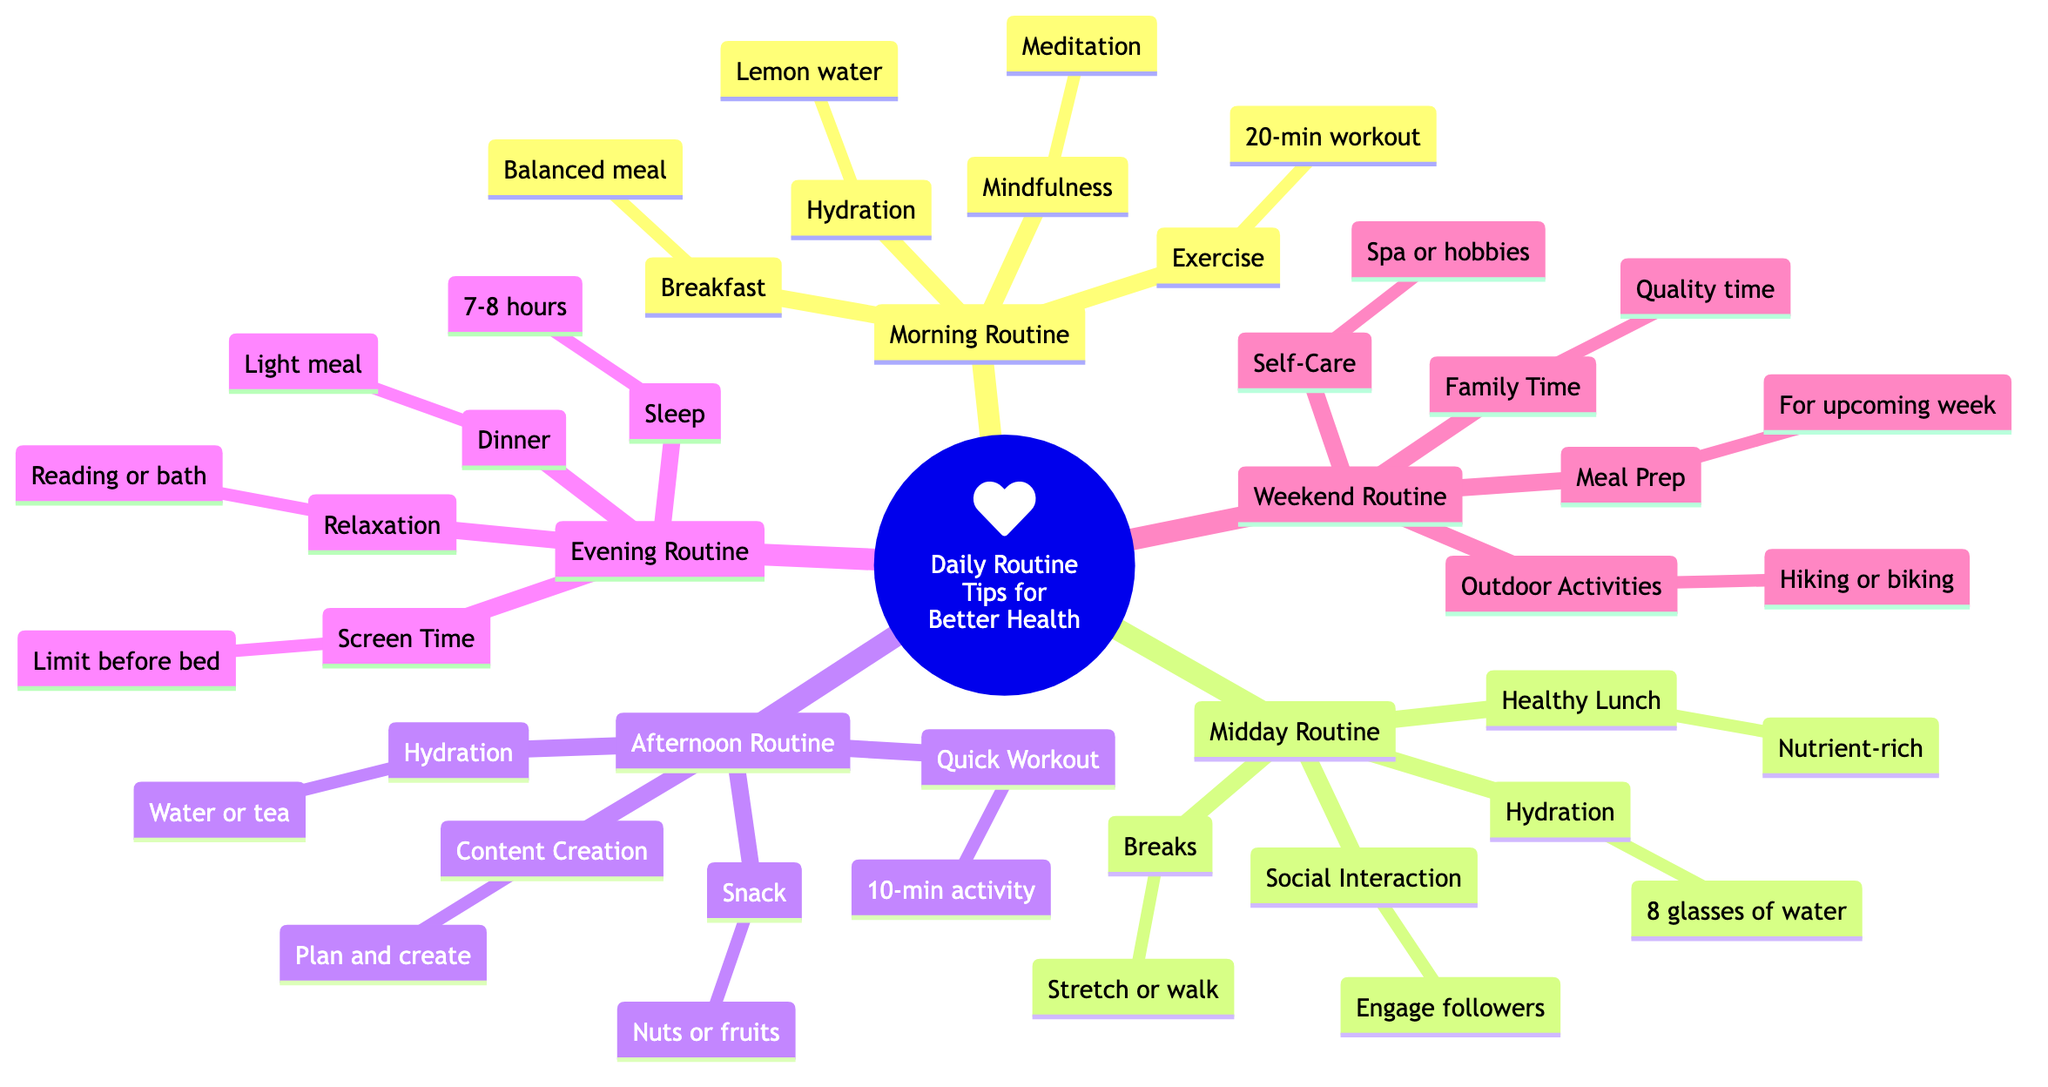what is the first suggestion in the morning routine? In the "Morning Routine" section of the mind map, the first listed suggestion is "Hydration," which recommends starting the day with a glass of lemon water.
Answer: Hydration how many nodes are in the evening routine? The "Evening Routine" contains four distinct nodes: "Dinner," "Relaxation," "Screen Time," and "Sleep." Thus, there are four nodes in total for this section.
Answer: 4 what activity is suggested for the morning mindfulness? The "Mindfulness" node in the "Morning Routine" specifically suggests spending 10 minutes meditating or practicing deep breathing.
Answer: Meditation which midday suggestion involves social media interaction? Under the "Midday Routine," there is a node labeled "Social Interaction," which encourages engaging with followers through positive posts or live sessions.
Answer: Engage followers what is the recommended meal type for the weekend routine's meal prep? The "Meal Prep" under the "Weekend Routine" advises preparing healthy meals for the upcoming week, indicating a focus on nutritious meal preparation.
Answer: Healthy meals is there a suggestion for physical activity in the afternoon routine? Yes, in the "Afternoon Routine," there is a node called "Quick Workout," which suggests incorporating a short, 10-minute physical activity.
Answer: 10-minute physical activity what hydration advice is given in the midday routine? The "Hydration" node in the "Midday Routine" states to drink at least eight 8-ounce glasses of water throughout the day, highlighting the importance of staying hydrated.
Answer: 8 glasses of water what is the primary focus of the weekend routine? The primary focus of the "Weekend Routine" includes engaging in outdoor activities, family time, meal prep, and self-care, suggesting a well-rounded approach to weekend wellness.
Answer: Outdoor activities what is suggested as a relaxation activity in the evening routine? The "Relaxation" node in the "Evening Routine" recommends unwinding with a relaxing activity like reading or taking a warm bath, promoting a peaceful transition to sleep.
Answer: Reading or bath 